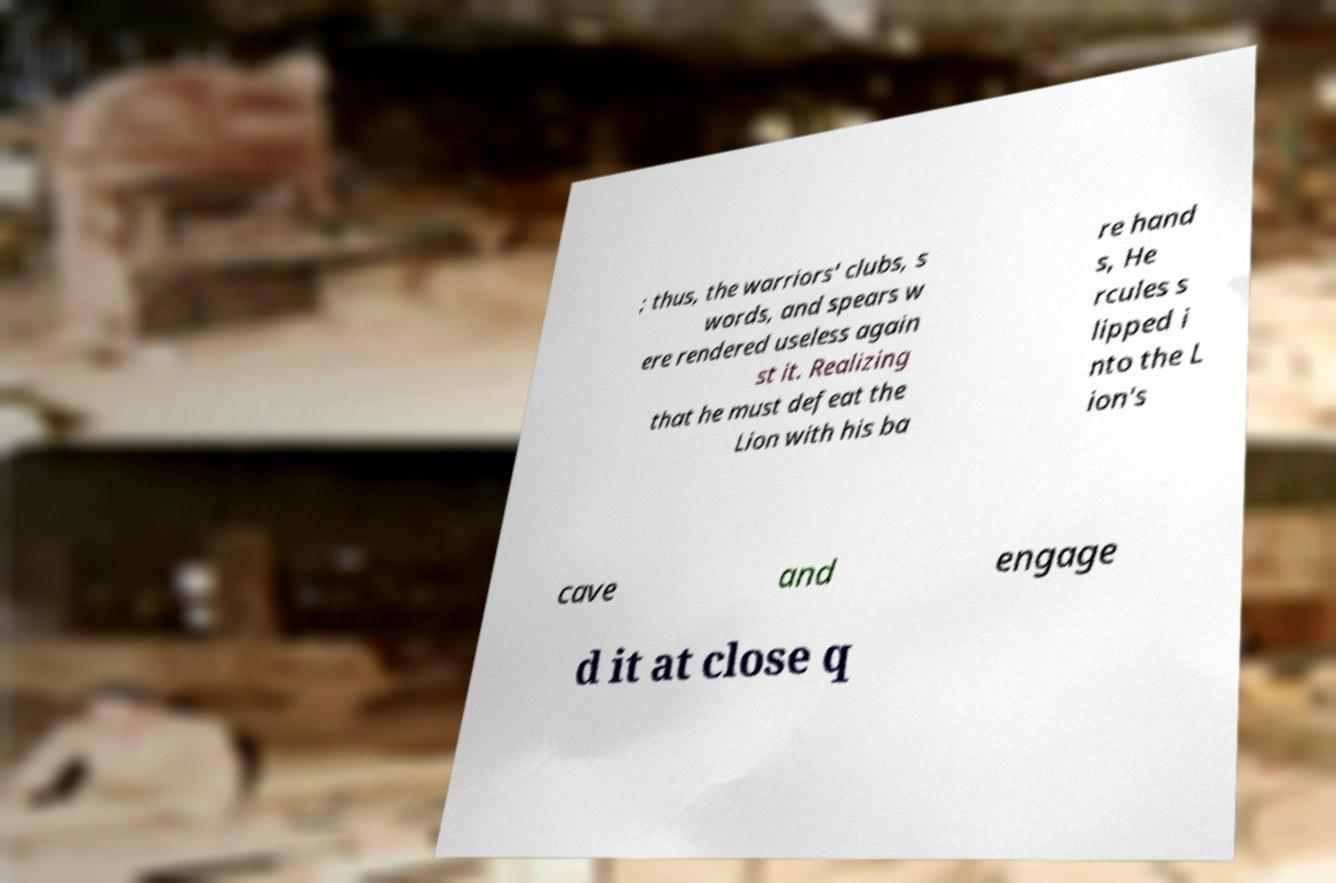What messages or text are displayed in this image? I need them in a readable, typed format. ; thus, the warriors' clubs, s words, and spears w ere rendered useless again st it. Realizing that he must defeat the Lion with his ba re hand s, He rcules s lipped i nto the L ion's cave and engage d it at close q 